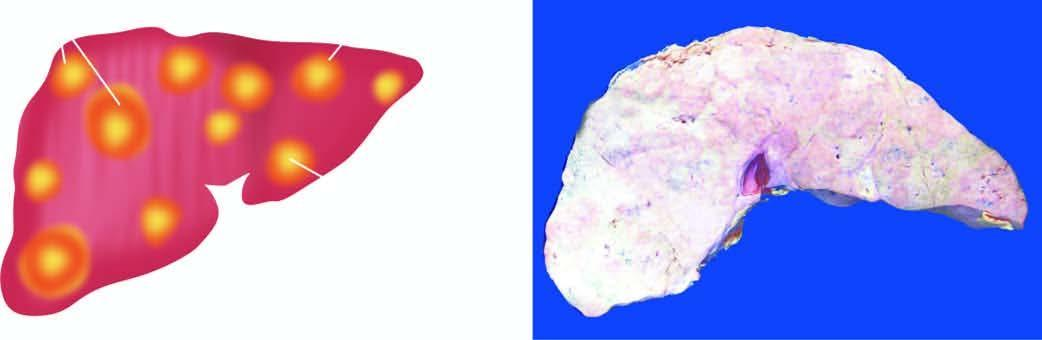what include multiple, variable-sized, nodular masses, often under the capsule, producing umbilication on the surface?
Answer the question using a single word or phrase. Characteristic features 